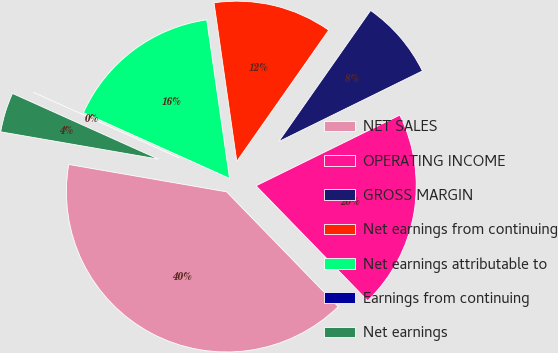<chart> <loc_0><loc_0><loc_500><loc_500><pie_chart><fcel>NET SALES<fcel>OPERATING INCOME<fcel>GROSS MARGIN<fcel>Net earnings from continuing<fcel>Net earnings attributable to<fcel>Earnings from continuing<fcel>Net earnings<nl><fcel>40.0%<fcel>20.0%<fcel>8.0%<fcel>12.0%<fcel>16.0%<fcel>0.0%<fcel>4.0%<nl></chart> 